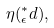Convert formula to latex. <formula><loc_0><loc_0><loc_500><loc_500>\eta ( ^ { * } _ { \epsilon } d ) ,</formula> 